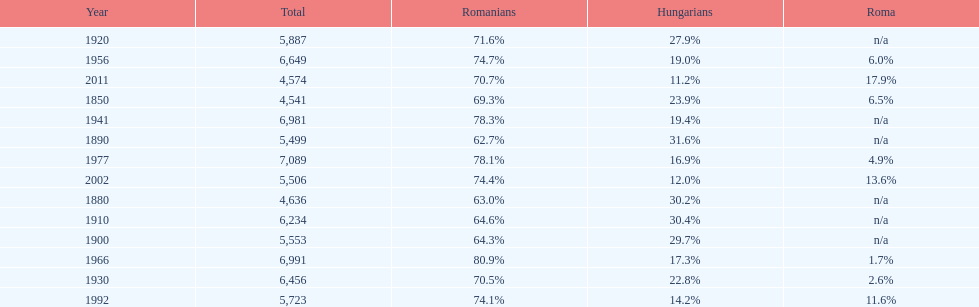What year had the next highest percentage for roma after 2011? 2002. 